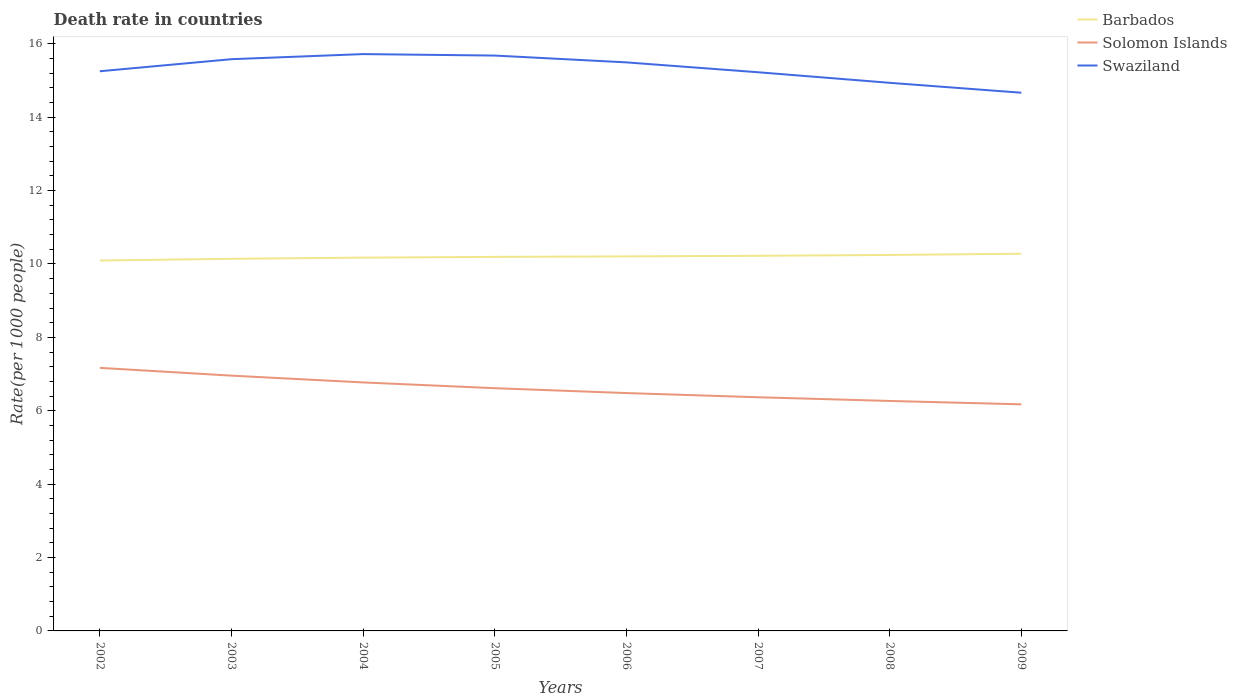Across all years, what is the maximum death rate in Swaziland?
Your response must be concise. 14.67. What is the total death rate in Swaziland in the graph?
Your answer should be compact. 1.05. What is the difference between the highest and the second highest death rate in Swaziland?
Provide a short and direct response. 1.05. Is the death rate in Swaziland strictly greater than the death rate in Solomon Islands over the years?
Give a very brief answer. No. How many lines are there?
Your answer should be compact. 3. Are the values on the major ticks of Y-axis written in scientific E-notation?
Provide a succinct answer. No. Does the graph contain any zero values?
Provide a short and direct response. No. Where does the legend appear in the graph?
Provide a short and direct response. Top right. How are the legend labels stacked?
Your answer should be very brief. Vertical. What is the title of the graph?
Ensure brevity in your answer.  Death rate in countries. Does "Seychelles" appear as one of the legend labels in the graph?
Keep it short and to the point. No. What is the label or title of the Y-axis?
Your response must be concise. Rate(per 1000 people). What is the Rate(per 1000 people) of Barbados in 2002?
Offer a very short reply. 10.1. What is the Rate(per 1000 people) of Solomon Islands in 2002?
Ensure brevity in your answer.  7.17. What is the Rate(per 1000 people) of Swaziland in 2002?
Your answer should be compact. 15.25. What is the Rate(per 1000 people) of Barbados in 2003?
Your answer should be very brief. 10.14. What is the Rate(per 1000 people) of Solomon Islands in 2003?
Your answer should be compact. 6.96. What is the Rate(per 1000 people) of Swaziland in 2003?
Your answer should be very brief. 15.58. What is the Rate(per 1000 people) of Barbados in 2004?
Provide a succinct answer. 10.17. What is the Rate(per 1000 people) in Solomon Islands in 2004?
Offer a terse response. 6.77. What is the Rate(per 1000 people) of Swaziland in 2004?
Your response must be concise. 15.72. What is the Rate(per 1000 people) of Barbados in 2005?
Keep it short and to the point. 10.19. What is the Rate(per 1000 people) of Solomon Islands in 2005?
Your answer should be compact. 6.62. What is the Rate(per 1000 people) in Swaziland in 2005?
Your answer should be very brief. 15.68. What is the Rate(per 1000 people) of Barbados in 2006?
Your answer should be very brief. 10.21. What is the Rate(per 1000 people) of Solomon Islands in 2006?
Provide a succinct answer. 6.48. What is the Rate(per 1000 people) in Swaziland in 2006?
Give a very brief answer. 15.49. What is the Rate(per 1000 people) of Barbados in 2007?
Give a very brief answer. 10.22. What is the Rate(per 1000 people) of Solomon Islands in 2007?
Offer a very short reply. 6.37. What is the Rate(per 1000 people) in Swaziland in 2007?
Your answer should be compact. 15.22. What is the Rate(per 1000 people) of Barbados in 2008?
Provide a short and direct response. 10.25. What is the Rate(per 1000 people) of Solomon Islands in 2008?
Ensure brevity in your answer.  6.27. What is the Rate(per 1000 people) in Swaziland in 2008?
Provide a succinct answer. 14.94. What is the Rate(per 1000 people) in Barbados in 2009?
Keep it short and to the point. 10.28. What is the Rate(per 1000 people) in Solomon Islands in 2009?
Provide a succinct answer. 6.17. What is the Rate(per 1000 people) in Swaziland in 2009?
Your answer should be compact. 14.67. Across all years, what is the maximum Rate(per 1000 people) in Barbados?
Offer a terse response. 10.28. Across all years, what is the maximum Rate(per 1000 people) of Solomon Islands?
Give a very brief answer. 7.17. Across all years, what is the maximum Rate(per 1000 people) in Swaziland?
Provide a succinct answer. 15.72. Across all years, what is the minimum Rate(per 1000 people) of Barbados?
Offer a very short reply. 10.1. Across all years, what is the minimum Rate(per 1000 people) of Solomon Islands?
Your response must be concise. 6.17. Across all years, what is the minimum Rate(per 1000 people) in Swaziland?
Offer a terse response. 14.67. What is the total Rate(per 1000 people) of Barbados in the graph?
Offer a terse response. 81.56. What is the total Rate(per 1000 people) of Solomon Islands in the graph?
Give a very brief answer. 52.8. What is the total Rate(per 1000 people) in Swaziland in the graph?
Offer a very short reply. 122.56. What is the difference between the Rate(per 1000 people) in Barbados in 2002 and that in 2003?
Give a very brief answer. -0.05. What is the difference between the Rate(per 1000 people) of Solomon Islands in 2002 and that in 2003?
Ensure brevity in your answer.  0.21. What is the difference between the Rate(per 1000 people) in Swaziland in 2002 and that in 2003?
Offer a terse response. -0.33. What is the difference between the Rate(per 1000 people) in Barbados in 2002 and that in 2004?
Provide a succinct answer. -0.08. What is the difference between the Rate(per 1000 people) in Solomon Islands in 2002 and that in 2004?
Your response must be concise. 0.4. What is the difference between the Rate(per 1000 people) in Swaziland in 2002 and that in 2004?
Give a very brief answer. -0.47. What is the difference between the Rate(per 1000 people) of Barbados in 2002 and that in 2005?
Your answer should be very brief. -0.1. What is the difference between the Rate(per 1000 people) of Solomon Islands in 2002 and that in 2005?
Your response must be concise. 0.55. What is the difference between the Rate(per 1000 people) in Swaziland in 2002 and that in 2005?
Provide a short and direct response. -0.43. What is the difference between the Rate(per 1000 people) of Barbados in 2002 and that in 2006?
Your response must be concise. -0.11. What is the difference between the Rate(per 1000 people) in Solomon Islands in 2002 and that in 2006?
Give a very brief answer. 0.69. What is the difference between the Rate(per 1000 people) in Swaziland in 2002 and that in 2006?
Your response must be concise. -0.24. What is the difference between the Rate(per 1000 people) in Barbados in 2002 and that in 2007?
Keep it short and to the point. -0.13. What is the difference between the Rate(per 1000 people) in Solomon Islands in 2002 and that in 2007?
Your answer should be very brief. 0.8. What is the difference between the Rate(per 1000 people) of Swaziland in 2002 and that in 2007?
Your response must be concise. 0.03. What is the difference between the Rate(per 1000 people) of Barbados in 2002 and that in 2008?
Provide a succinct answer. -0.15. What is the difference between the Rate(per 1000 people) of Solomon Islands in 2002 and that in 2008?
Your response must be concise. 0.9. What is the difference between the Rate(per 1000 people) of Swaziland in 2002 and that in 2008?
Keep it short and to the point. 0.32. What is the difference between the Rate(per 1000 people) of Barbados in 2002 and that in 2009?
Your answer should be very brief. -0.18. What is the difference between the Rate(per 1000 people) in Swaziland in 2002 and that in 2009?
Offer a terse response. 0.58. What is the difference between the Rate(per 1000 people) in Barbados in 2003 and that in 2004?
Give a very brief answer. -0.03. What is the difference between the Rate(per 1000 people) of Solomon Islands in 2003 and that in 2004?
Your answer should be very brief. 0.18. What is the difference between the Rate(per 1000 people) of Swaziland in 2003 and that in 2004?
Provide a succinct answer. -0.14. What is the difference between the Rate(per 1000 people) of Barbados in 2003 and that in 2005?
Keep it short and to the point. -0.05. What is the difference between the Rate(per 1000 people) in Solomon Islands in 2003 and that in 2005?
Your answer should be compact. 0.34. What is the difference between the Rate(per 1000 people) of Swaziland in 2003 and that in 2005?
Your answer should be compact. -0.1. What is the difference between the Rate(per 1000 people) in Barbados in 2003 and that in 2006?
Provide a short and direct response. -0.07. What is the difference between the Rate(per 1000 people) of Solomon Islands in 2003 and that in 2006?
Your answer should be very brief. 0.47. What is the difference between the Rate(per 1000 people) in Swaziland in 2003 and that in 2006?
Make the answer very short. 0.09. What is the difference between the Rate(per 1000 people) in Barbados in 2003 and that in 2007?
Give a very brief answer. -0.08. What is the difference between the Rate(per 1000 people) of Solomon Islands in 2003 and that in 2007?
Give a very brief answer. 0.59. What is the difference between the Rate(per 1000 people) in Swaziland in 2003 and that in 2007?
Keep it short and to the point. 0.36. What is the difference between the Rate(per 1000 people) in Barbados in 2003 and that in 2008?
Ensure brevity in your answer.  -0.1. What is the difference between the Rate(per 1000 people) in Solomon Islands in 2003 and that in 2008?
Offer a very short reply. 0.69. What is the difference between the Rate(per 1000 people) of Swaziland in 2003 and that in 2008?
Make the answer very short. 0.64. What is the difference between the Rate(per 1000 people) of Barbados in 2003 and that in 2009?
Offer a very short reply. -0.14. What is the difference between the Rate(per 1000 people) in Solomon Islands in 2003 and that in 2009?
Offer a terse response. 0.78. What is the difference between the Rate(per 1000 people) in Swaziland in 2003 and that in 2009?
Make the answer very short. 0.91. What is the difference between the Rate(per 1000 people) of Barbados in 2004 and that in 2005?
Keep it short and to the point. -0.02. What is the difference between the Rate(per 1000 people) in Solomon Islands in 2004 and that in 2005?
Offer a terse response. 0.16. What is the difference between the Rate(per 1000 people) in Swaziland in 2004 and that in 2005?
Keep it short and to the point. 0.04. What is the difference between the Rate(per 1000 people) in Barbados in 2004 and that in 2006?
Your answer should be compact. -0.03. What is the difference between the Rate(per 1000 people) of Solomon Islands in 2004 and that in 2006?
Provide a succinct answer. 0.29. What is the difference between the Rate(per 1000 people) in Swaziland in 2004 and that in 2006?
Offer a terse response. 0.23. What is the difference between the Rate(per 1000 people) in Solomon Islands in 2004 and that in 2007?
Your answer should be very brief. 0.4. What is the difference between the Rate(per 1000 people) in Swaziland in 2004 and that in 2007?
Make the answer very short. 0.49. What is the difference between the Rate(per 1000 people) in Barbados in 2004 and that in 2008?
Provide a short and direct response. -0.07. What is the difference between the Rate(per 1000 people) of Solomon Islands in 2004 and that in 2008?
Give a very brief answer. 0.51. What is the difference between the Rate(per 1000 people) of Swaziland in 2004 and that in 2008?
Your answer should be very brief. 0.78. What is the difference between the Rate(per 1000 people) of Barbados in 2004 and that in 2009?
Provide a succinct answer. -0.11. What is the difference between the Rate(per 1000 people) in Solomon Islands in 2004 and that in 2009?
Your response must be concise. 0.6. What is the difference between the Rate(per 1000 people) in Swaziland in 2004 and that in 2009?
Offer a terse response. 1.05. What is the difference between the Rate(per 1000 people) of Barbados in 2005 and that in 2006?
Keep it short and to the point. -0.01. What is the difference between the Rate(per 1000 people) in Solomon Islands in 2005 and that in 2006?
Your response must be concise. 0.13. What is the difference between the Rate(per 1000 people) of Swaziland in 2005 and that in 2006?
Keep it short and to the point. 0.19. What is the difference between the Rate(per 1000 people) in Barbados in 2005 and that in 2007?
Provide a succinct answer. -0.03. What is the difference between the Rate(per 1000 people) of Solomon Islands in 2005 and that in 2007?
Your answer should be very brief. 0.25. What is the difference between the Rate(per 1000 people) in Swaziland in 2005 and that in 2007?
Make the answer very short. 0.46. What is the difference between the Rate(per 1000 people) in Barbados in 2005 and that in 2008?
Provide a succinct answer. -0.05. What is the difference between the Rate(per 1000 people) in Solomon Islands in 2005 and that in 2008?
Offer a very short reply. 0.35. What is the difference between the Rate(per 1000 people) of Swaziland in 2005 and that in 2008?
Provide a short and direct response. 0.74. What is the difference between the Rate(per 1000 people) in Barbados in 2005 and that in 2009?
Provide a succinct answer. -0.09. What is the difference between the Rate(per 1000 people) of Solomon Islands in 2005 and that in 2009?
Keep it short and to the point. 0.44. What is the difference between the Rate(per 1000 people) of Barbados in 2006 and that in 2007?
Your answer should be very brief. -0.02. What is the difference between the Rate(per 1000 people) of Solomon Islands in 2006 and that in 2007?
Keep it short and to the point. 0.11. What is the difference between the Rate(per 1000 people) of Swaziland in 2006 and that in 2007?
Your response must be concise. 0.27. What is the difference between the Rate(per 1000 people) in Barbados in 2006 and that in 2008?
Offer a terse response. -0.04. What is the difference between the Rate(per 1000 people) in Solomon Islands in 2006 and that in 2008?
Make the answer very short. 0.21. What is the difference between the Rate(per 1000 people) of Swaziland in 2006 and that in 2008?
Your answer should be very brief. 0.56. What is the difference between the Rate(per 1000 people) of Barbados in 2006 and that in 2009?
Offer a terse response. -0.07. What is the difference between the Rate(per 1000 people) of Solomon Islands in 2006 and that in 2009?
Provide a succinct answer. 0.31. What is the difference between the Rate(per 1000 people) of Swaziland in 2006 and that in 2009?
Provide a short and direct response. 0.83. What is the difference between the Rate(per 1000 people) of Barbados in 2007 and that in 2008?
Provide a succinct answer. -0.02. What is the difference between the Rate(per 1000 people) of Solomon Islands in 2007 and that in 2008?
Give a very brief answer. 0.1. What is the difference between the Rate(per 1000 people) in Swaziland in 2007 and that in 2008?
Ensure brevity in your answer.  0.29. What is the difference between the Rate(per 1000 people) in Barbados in 2007 and that in 2009?
Offer a very short reply. -0.06. What is the difference between the Rate(per 1000 people) in Solomon Islands in 2007 and that in 2009?
Offer a terse response. 0.19. What is the difference between the Rate(per 1000 people) in Swaziland in 2007 and that in 2009?
Your response must be concise. 0.56. What is the difference between the Rate(per 1000 people) in Barbados in 2008 and that in 2009?
Provide a succinct answer. -0.03. What is the difference between the Rate(per 1000 people) of Solomon Islands in 2008 and that in 2009?
Keep it short and to the point. 0.09. What is the difference between the Rate(per 1000 people) of Swaziland in 2008 and that in 2009?
Ensure brevity in your answer.  0.27. What is the difference between the Rate(per 1000 people) in Barbados in 2002 and the Rate(per 1000 people) in Solomon Islands in 2003?
Make the answer very short. 3.14. What is the difference between the Rate(per 1000 people) of Barbados in 2002 and the Rate(per 1000 people) of Swaziland in 2003?
Your response must be concise. -5.49. What is the difference between the Rate(per 1000 people) of Solomon Islands in 2002 and the Rate(per 1000 people) of Swaziland in 2003?
Offer a very short reply. -8.41. What is the difference between the Rate(per 1000 people) in Barbados in 2002 and the Rate(per 1000 people) in Solomon Islands in 2004?
Provide a short and direct response. 3.32. What is the difference between the Rate(per 1000 people) in Barbados in 2002 and the Rate(per 1000 people) in Swaziland in 2004?
Make the answer very short. -5.62. What is the difference between the Rate(per 1000 people) in Solomon Islands in 2002 and the Rate(per 1000 people) in Swaziland in 2004?
Give a very brief answer. -8.55. What is the difference between the Rate(per 1000 people) of Barbados in 2002 and the Rate(per 1000 people) of Solomon Islands in 2005?
Your answer should be very brief. 3.48. What is the difference between the Rate(per 1000 people) in Barbados in 2002 and the Rate(per 1000 people) in Swaziland in 2005?
Make the answer very short. -5.58. What is the difference between the Rate(per 1000 people) in Solomon Islands in 2002 and the Rate(per 1000 people) in Swaziland in 2005?
Offer a very short reply. -8.51. What is the difference between the Rate(per 1000 people) in Barbados in 2002 and the Rate(per 1000 people) in Solomon Islands in 2006?
Your answer should be very brief. 3.61. What is the difference between the Rate(per 1000 people) in Barbados in 2002 and the Rate(per 1000 people) in Swaziland in 2006?
Ensure brevity in your answer.  -5.4. What is the difference between the Rate(per 1000 people) in Solomon Islands in 2002 and the Rate(per 1000 people) in Swaziland in 2006?
Make the answer very short. -8.32. What is the difference between the Rate(per 1000 people) in Barbados in 2002 and the Rate(per 1000 people) in Solomon Islands in 2007?
Ensure brevity in your answer.  3.73. What is the difference between the Rate(per 1000 people) in Barbados in 2002 and the Rate(per 1000 people) in Swaziland in 2007?
Provide a short and direct response. -5.13. What is the difference between the Rate(per 1000 people) in Solomon Islands in 2002 and the Rate(per 1000 people) in Swaziland in 2007?
Your response must be concise. -8.06. What is the difference between the Rate(per 1000 people) in Barbados in 2002 and the Rate(per 1000 people) in Solomon Islands in 2008?
Give a very brief answer. 3.83. What is the difference between the Rate(per 1000 people) in Barbados in 2002 and the Rate(per 1000 people) in Swaziland in 2008?
Your answer should be very brief. -4.84. What is the difference between the Rate(per 1000 people) of Solomon Islands in 2002 and the Rate(per 1000 people) of Swaziland in 2008?
Keep it short and to the point. -7.77. What is the difference between the Rate(per 1000 people) of Barbados in 2002 and the Rate(per 1000 people) of Solomon Islands in 2009?
Make the answer very short. 3.92. What is the difference between the Rate(per 1000 people) of Barbados in 2002 and the Rate(per 1000 people) of Swaziland in 2009?
Offer a very short reply. -4.57. What is the difference between the Rate(per 1000 people) of Solomon Islands in 2002 and the Rate(per 1000 people) of Swaziland in 2009?
Provide a short and direct response. -7.5. What is the difference between the Rate(per 1000 people) of Barbados in 2003 and the Rate(per 1000 people) of Solomon Islands in 2004?
Ensure brevity in your answer.  3.37. What is the difference between the Rate(per 1000 people) in Barbados in 2003 and the Rate(per 1000 people) in Swaziland in 2004?
Your answer should be very brief. -5.58. What is the difference between the Rate(per 1000 people) in Solomon Islands in 2003 and the Rate(per 1000 people) in Swaziland in 2004?
Your response must be concise. -8.76. What is the difference between the Rate(per 1000 people) of Barbados in 2003 and the Rate(per 1000 people) of Solomon Islands in 2005?
Your answer should be compact. 3.53. What is the difference between the Rate(per 1000 people) in Barbados in 2003 and the Rate(per 1000 people) in Swaziland in 2005?
Provide a short and direct response. -5.54. What is the difference between the Rate(per 1000 people) of Solomon Islands in 2003 and the Rate(per 1000 people) of Swaziland in 2005?
Your answer should be very brief. -8.72. What is the difference between the Rate(per 1000 people) in Barbados in 2003 and the Rate(per 1000 people) in Solomon Islands in 2006?
Make the answer very short. 3.66. What is the difference between the Rate(per 1000 people) in Barbados in 2003 and the Rate(per 1000 people) in Swaziland in 2006?
Provide a succinct answer. -5.35. What is the difference between the Rate(per 1000 people) in Solomon Islands in 2003 and the Rate(per 1000 people) in Swaziland in 2006?
Offer a terse response. -8.54. What is the difference between the Rate(per 1000 people) of Barbados in 2003 and the Rate(per 1000 people) of Solomon Islands in 2007?
Keep it short and to the point. 3.77. What is the difference between the Rate(per 1000 people) of Barbados in 2003 and the Rate(per 1000 people) of Swaziland in 2007?
Give a very brief answer. -5.08. What is the difference between the Rate(per 1000 people) in Solomon Islands in 2003 and the Rate(per 1000 people) in Swaziland in 2007?
Make the answer very short. -8.27. What is the difference between the Rate(per 1000 people) of Barbados in 2003 and the Rate(per 1000 people) of Solomon Islands in 2008?
Your answer should be very brief. 3.87. What is the difference between the Rate(per 1000 people) in Barbados in 2003 and the Rate(per 1000 people) in Swaziland in 2008?
Your response must be concise. -4.8. What is the difference between the Rate(per 1000 people) of Solomon Islands in 2003 and the Rate(per 1000 people) of Swaziland in 2008?
Your response must be concise. -7.98. What is the difference between the Rate(per 1000 people) in Barbados in 2003 and the Rate(per 1000 people) in Solomon Islands in 2009?
Provide a succinct answer. 3.97. What is the difference between the Rate(per 1000 people) in Barbados in 2003 and the Rate(per 1000 people) in Swaziland in 2009?
Offer a very short reply. -4.53. What is the difference between the Rate(per 1000 people) of Solomon Islands in 2003 and the Rate(per 1000 people) of Swaziland in 2009?
Your answer should be very brief. -7.71. What is the difference between the Rate(per 1000 people) of Barbados in 2004 and the Rate(per 1000 people) of Solomon Islands in 2005?
Your answer should be compact. 3.56. What is the difference between the Rate(per 1000 people) of Barbados in 2004 and the Rate(per 1000 people) of Swaziland in 2005?
Give a very brief answer. -5.51. What is the difference between the Rate(per 1000 people) in Solomon Islands in 2004 and the Rate(per 1000 people) in Swaziland in 2005?
Provide a short and direct response. -8.91. What is the difference between the Rate(per 1000 people) of Barbados in 2004 and the Rate(per 1000 people) of Solomon Islands in 2006?
Your answer should be compact. 3.69. What is the difference between the Rate(per 1000 people) in Barbados in 2004 and the Rate(per 1000 people) in Swaziland in 2006?
Provide a succinct answer. -5.32. What is the difference between the Rate(per 1000 people) of Solomon Islands in 2004 and the Rate(per 1000 people) of Swaziland in 2006?
Ensure brevity in your answer.  -8.72. What is the difference between the Rate(per 1000 people) of Barbados in 2004 and the Rate(per 1000 people) of Solomon Islands in 2007?
Your answer should be compact. 3.81. What is the difference between the Rate(per 1000 people) in Barbados in 2004 and the Rate(per 1000 people) in Swaziland in 2007?
Offer a terse response. -5.05. What is the difference between the Rate(per 1000 people) of Solomon Islands in 2004 and the Rate(per 1000 people) of Swaziland in 2007?
Your response must be concise. -8.45. What is the difference between the Rate(per 1000 people) in Barbados in 2004 and the Rate(per 1000 people) in Solomon Islands in 2008?
Provide a short and direct response. 3.91. What is the difference between the Rate(per 1000 people) of Barbados in 2004 and the Rate(per 1000 people) of Swaziland in 2008?
Your answer should be compact. -4.76. What is the difference between the Rate(per 1000 people) of Solomon Islands in 2004 and the Rate(per 1000 people) of Swaziland in 2008?
Make the answer very short. -8.16. What is the difference between the Rate(per 1000 people) of Barbados in 2004 and the Rate(per 1000 people) of Solomon Islands in 2009?
Offer a very short reply. 4. What is the difference between the Rate(per 1000 people) in Barbados in 2004 and the Rate(per 1000 people) in Swaziland in 2009?
Keep it short and to the point. -4.49. What is the difference between the Rate(per 1000 people) of Solomon Islands in 2004 and the Rate(per 1000 people) of Swaziland in 2009?
Your answer should be very brief. -7.89. What is the difference between the Rate(per 1000 people) of Barbados in 2005 and the Rate(per 1000 people) of Solomon Islands in 2006?
Your answer should be very brief. 3.71. What is the difference between the Rate(per 1000 people) in Barbados in 2005 and the Rate(per 1000 people) in Swaziland in 2006?
Your response must be concise. -5.3. What is the difference between the Rate(per 1000 people) in Solomon Islands in 2005 and the Rate(per 1000 people) in Swaziland in 2006?
Your answer should be very brief. -8.88. What is the difference between the Rate(per 1000 people) in Barbados in 2005 and the Rate(per 1000 people) in Solomon Islands in 2007?
Offer a terse response. 3.83. What is the difference between the Rate(per 1000 people) of Barbados in 2005 and the Rate(per 1000 people) of Swaziland in 2007?
Provide a short and direct response. -5.03. What is the difference between the Rate(per 1000 people) of Solomon Islands in 2005 and the Rate(per 1000 people) of Swaziland in 2007?
Your answer should be compact. -8.61. What is the difference between the Rate(per 1000 people) of Barbados in 2005 and the Rate(per 1000 people) of Solomon Islands in 2008?
Offer a terse response. 3.93. What is the difference between the Rate(per 1000 people) of Barbados in 2005 and the Rate(per 1000 people) of Swaziland in 2008?
Offer a terse response. -4.74. What is the difference between the Rate(per 1000 people) of Solomon Islands in 2005 and the Rate(per 1000 people) of Swaziland in 2008?
Offer a very short reply. -8.32. What is the difference between the Rate(per 1000 people) of Barbados in 2005 and the Rate(per 1000 people) of Solomon Islands in 2009?
Provide a short and direct response. 4.02. What is the difference between the Rate(per 1000 people) in Barbados in 2005 and the Rate(per 1000 people) in Swaziland in 2009?
Offer a very short reply. -4.47. What is the difference between the Rate(per 1000 people) in Solomon Islands in 2005 and the Rate(per 1000 people) in Swaziland in 2009?
Keep it short and to the point. -8.05. What is the difference between the Rate(per 1000 people) in Barbados in 2006 and the Rate(per 1000 people) in Solomon Islands in 2007?
Your answer should be compact. 3.84. What is the difference between the Rate(per 1000 people) in Barbados in 2006 and the Rate(per 1000 people) in Swaziland in 2007?
Your response must be concise. -5.02. What is the difference between the Rate(per 1000 people) of Solomon Islands in 2006 and the Rate(per 1000 people) of Swaziland in 2007?
Keep it short and to the point. -8.74. What is the difference between the Rate(per 1000 people) in Barbados in 2006 and the Rate(per 1000 people) in Solomon Islands in 2008?
Make the answer very short. 3.94. What is the difference between the Rate(per 1000 people) of Barbados in 2006 and the Rate(per 1000 people) of Swaziland in 2008?
Provide a short and direct response. -4.73. What is the difference between the Rate(per 1000 people) in Solomon Islands in 2006 and the Rate(per 1000 people) in Swaziland in 2008?
Make the answer very short. -8.46. What is the difference between the Rate(per 1000 people) of Barbados in 2006 and the Rate(per 1000 people) of Solomon Islands in 2009?
Provide a short and direct response. 4.03. What is the difference between the Rate(per 1000 people) of Barbados in 2006 and the Rate(per 1000 people) of Swaziland in 2009?
Provide a succinct answer. -4.46. What is the difference between the Rate(per 1000 people) in Solomon Islands in 2006 and the Rate(per 1000 people) in Swaziland in 2009?
Provide a succinct answer. -8.19. What is the difference between the Rate(per 1000 people) of Barbados in 2007 and the Rate(per 1000 people) of Solomon Islands in 2008?
Provide a short and direct response. 3.96. What is the difference between the Rate(per 1000 people) in Barbados in 2007 and the Rate(per 1000 people) in Swaziland in 2008?
Your answer should be very brief. -4.71. What is the difference between the Rate(per 1000 people) of Solomon Islands in 2007 and the Rate(per 1000 people) of Swaziland in 2008?
Your answer should be very brief. -8.57. What is the difference between the Rate(per 1000 people) in Barbados in 2007 and the Rate(per 1000 people) in Solomon Islands in 2009?
Your answer should be very brief. 4.05. What is the difference between the Rate(per 1000 people) of Barbados in 2007 and the Rate(per 1000 people) of Swaziland in 2009?
Provide a short and direct response. -4.44. What is the difference between the Rate(per 1000 people) of Solomon Islands in 2007 and the Rate(per 1000 people) of Swaziland in 2009?
Ensure brevity in your answer.  -8.3. What is the difference between the Rate(per 1000 people) in Barbados in 2008 and the Rate(per 1000 people) in Solomon Islands in 2009?
Your answer should be very brief. 4.07. What is the difference between the Rate(per 1000 people) in Barbados in 2008 and the Rate(per 1000 people) in Swaziland in 2009?
Keep it short and to the point. -4.42. What is the average Rate(per 1000 people) of Barbados per year?
Make the answer very short. 10.19. What is the average Rate(per 1000 people) in Solomon Islands per year?
Ensure brevity in your answer.  6.6. What is the average Rate(per 1000 people) of Swaziland per year?
Your response must be concise. 15.32. In the year 2002, what is the difference between the Rate(per 1000 people) in Barbados and Rate(per 1000 people) in Solomon Islands?
Your answer should be very brief. 2.93. In the year 2002, what is the difference between the Rate(per 1000 people) of Barbados and Rate(per 1000 people) of Swaziland?
Offer a very short reply. -5.16. In the year 2002, what is the difference between the Rate(per 1000 people) of Solomon Islands and Rate(per 1000 people) of Swaziland?
Ensure brevity in your answer.  -8.08. In the year 2003, what is the difference between the Rate(per 1000 people) in Barbados and Rate(per 1000 people) in Solomon Islands?
Provide a succinct answer. 3.18. In the year 2003, what is the difference between the Rate(per 1000 people) in Barbados and Rate(per 1000 people) in Swaziland?
Ensure brevity in your answer.  -5.44. In the year 2003, what is the difference between the Rate(per 1000 people) of Solomon Islands and Rate(per 1000 people) of Swaziland?
Keep it short and to the point. -8.62. In the year 2004, what is the difference between the Rate(per 1000 people) of Barbados and Rate(per 1000 people) of Solomon Islands?
Your response must be concise. 3.4. In the year 2004, what is the difference between the Rate(per 1000 people) of Barbados and Rate(per 1000 people) of Swaziland?
Provide a succinct answer. -5.55. In the year 2004, what is the difference between the Rate(per 1000 people) of Solomon Islands and Rate(per 1000 people) of Swaziland?
Provide a succinct answer. -8.95. In the year 2005, what is the difference between the Rate(per 1000 people) of Barbados and Rate(per 1000 people) of Solomon Islands?
Your response must be concise. 3.58. In the year 2005, what is the difference between the Rate(per 1000 people) in Barbados and Rate(per 1000 people) in Swaziland?
Offer a very short reply. -5.49. In the year 2005, what is the difference between the Rate(per 1000 people) of Solomon Islands and Rate(per 1000 people) of Swaziland?
Provide a short and direct response. -9.06. In the year 2006, what is the difference between the Rate(per 1000 people) of Barbados and Rate(per 1000 people) of Solomon Islands?
Provide a short and direct response. 3.73. In the year 2006, what is the difference between the Rate(per 1000 people) of Barbados and Rate(per 1000 people) of Swaziland?
Keep it short and to the point. -5.29. In the year 2006, what is the difference between the Rate(per 1000 people) of Solomon Islands and Rate(per 1000 people) of Swaziland?
Your answer should be compact. -9.01. In the year 2007, what is the difference between the Rate(per 1000 people) of Barbados and Rate(per 1000 people) of Solomon Islands?
Ensure brevity in your answer.  3.85. In the year 2007, what is the difference between the Rate(per 1000 people) in Barbados and Rate(per 1000 people) in Swaziland?
Your response must be concise. -5. In the year 2007, what is the difference between the Rate(per 1000 people) of Solomon Islands and Rate(per 1000 people) of Swaziland?
Your answer should be very brief. -8.86. In the year 2008, what is the difference between the Rate(per 1000 people) of Barbados and Rate(per 1000 people) of Solomon Islands?
Provide a short and direct response. 3.98. In the year 2008, what is the difference between the Rate(per 1000 people) in Barbados and Rate(per 1000 people) in Swaziland?
Provide a short and direct response. -4.69. In the year 2008, what is the difference between the Rate(per 1000 people) in Solomon Islands and Rate(per 1000 people) in Swaziland?
Your answer should be compact. -8.67. In the year 2009, what is the difference between the Rate(per 1000 people) of Barbados and Rate(per 1000 people) of Solomon Islands?
Offer a very short reply. 4.1. In the year 2009, what is the difference between the Rate(per 1000 people) of Barbados and Rate(per 1000 people) of Swaziland?
Give a very brief answer. -4.39. In the year 2009, what is the difference between the Rate(per 1000 people) of Solomon Islands and Rate(per 1000 people) of Swaziland?
Give a very brief answer. -8.49. What is the ratio of the Rate(per 1000 people) of Barbados in 2002 to that in 2003?
Offer a terse response. 1. What is the ratio of the Rate(per 1000 people) of Solomon Islands in 2002 to that in 2003?
Your answer should be compact. 1.03. What is the ratio of the Rate(per 1000 people) of Swaziland in 2002 to that in 2003?
Make the answer very short. 0.98. What is the ratio of the Rate(per 1000 people) in Solomon Islands in 2002 to that in 2004?
Provide a short and direct response. 1.06. What is the ratio of the Rate(per 1000 people) in Swaziland in 2002 to that in 2004?
Provide a short and direct response. 0.97. What is the ratio of the Rate(per 1000 people) of Solomon Islands in 2002 to that in 2005?
Your answer should be very brief. 1.08. What is the ratio of the Rate(per 1000 people) in Swaziland in 2002 to that in 2005?
Ensure brevity in your answer.  0.97. What is the ratio of the Rate(per 1000 people) of Barbados in 2002 to that in 2006?
Give a very brief answer. 0.99. What is the ratio of the Rate(per 1000 people) of Solomon Islands in 2002 to that in 2006?
Keep it short and to the point. 1.11. What is the ratio of the Rate(per 1000 people) of Swaziland in 2002 to that in 2006?
Provide a succinct answer. 0.98. What is the ratio of the Rate(per 1000 people) in Barbados in 2002 to that in 2007?
Make the answer very short. 0.99. What is the ratio of the Rate(per 1000 people) in Solomon Islands in 2002 to that in 2007?
Offer a terse response. 1.13. What is the ratio of the Rate(per 1000 people) in Swaziland in 2002 to that in 2007?
Give a very brief answer. 1. What is the ratio of the Rate(per 1000 people) in Barbados in 2002 to that in 2008?
Offer a very short reply. 0.99. What is the ratio of the Rate(per 1000 people) in Solomon Islands in 2002 to that in 2008?
Your answer should be compact. 1.14. What is the ratio of the Rate(per 1000 people) in Swaziland in 2002 to that in 2008?
Offer a very short reply. 1.02. What is the ratio of the Rate(per 1000 people) in Barbados in 2002 to that in 2009?
Make the answer very short. 0.98. What is the ratio of the Rate(per 1000 people) in Solomon Islands in 2002 to that in 2009?
Ensure brevity in your answer.  1.16. What is the ratio of the Rate(per 1000 people) of Swaziland in 2002 to that in 2009?
Offer a terse response. 1.04. What is the ratio of the Rate(per 1000 people) in Solomon Islands in 2003 to that in 2004?
Your answer should be compact. 1.03. What is the ratio of the Rate(per 1000 people) in Solomon Islands in 2003 to that in 2005?
Give a very brief answer. 1.05. What is the ratio of the Rate(per 1000 people) in Swaziland in 2003 to that in 2005?
Offer a very short reply. 0.99. What is the ratio of the Rate(per 1000 people) in Barbados in 2003 to that in 2006?
Give a very brief answer. 0.99. What is the ratio of the Rate(per 1000 people) of Solomon Islands in 2003 to that in 2006?
Ensure brevity in your answer.  1.07. What is the ratio of the Rate(per 1000 people) in Swaziland in 2003 to that in 2006?
Provide a short and direct response. 1.01. What is the ratio of the Rate(per 1000 people) in Barbados in 2003 to that in 2007?
Make the answer very short. 0.99. What is the ratio of the Rate(per 1000 people) of Solomon Islands in 2003 to that in 2007?
Offer a terse response. 1.09. What is the ratio of the Rate(per 1000 people) in Swaziland in 2003 to that in 2007?
Your response must be concise. 1.02. What is the ratio of the Rate(per 1000 people) in Barbados in 2003 to that in 2008?
Keep it short and to the point. 0.99. What is the ratio of the Rate(per 1000 people) of Solomon Islands in 2003 to that in 2008?
Your answer should be very brief. 1.11. What is the ratio of the Rate(per 1000 people) in Swaziland in 2003 to that in 2008?
Provide a succinct answer. 1.04. What is the ratio of the Rate(per 1000 people) of Barbados in 2003 to that in 2009?
Provide a succinct answer. 0.99. What is the ratio of the Rate(per 1000 people) in Solomon Islands in 2003 to that in 2009?
Your response must be concise. 1.13. What is the ratio of the Rate(per 1000 people) of Swaziland in 2003 to that in 2009?
Offer a very short reply. 1.06. What is the ratio of the Rate(per 1000 people) of Solomon Islands in 2004 to that in 2005?
Your answer should be very brief. 1.02. What is the ratio of the Rate(per 1000 people) in Swaziland in 2004 to that in 2005?
Offer a terse response. 1. What is the ratio of the Rate(per 1000 people) in Solomon Islands in 2004 to that in 2006?
Make the answer very short. 1.04. What is the ratio of the Rate(per 1000 people) in Swaziland in 2004 to that in 2006?
Your response must be concise. 1.01. What is the ratio of the Rate(per 1000 people) of Barbados in 2004 to that in 2007?
Keep it short and to the point. 1. What is the ratio of the Rate(per 1000 people) in Solomon Islands in 2004 to that in 2007?
Your answer should be compact. 1.06. What is the ratio of the Rate(per 1000 people) in Swaziland in 2004 to that in 2007?
Your answer should be compact. 1.03. What is the ratio of the Rate(per 1000 people) of Barbados in 2004 to that in 2008?
Provide a short and direct response. 0.99. What is the ratio of the Rate(per 1000 people) of Solomon Islands in 2004 to that in 2008?
Your answer should be very brief. 1.08. What is the ratio of the Rate(per 1000 people) of Swaziland in 2004 to that in 2008?
Provide a short and direct response. 1.05. What is the ratio of the Rate(per 1000 people) of Barbados in 2004 to that in 2009?
Your answer should be compact. 0.99. What is the ratio of the Rate(per 1000 people) in Solomon Islands in 2004 to that in 2009?
Your answer should be very brief. 1.1. What is the ratio of the Rate(per 1000 people) of Swaziland in 2004 to that in 2009?
Ensure brevity in your answer.  1.07. What is the ratio of the Rate(per 1000 people) of Barbados in 2005 to that in 2006?
Give a very brief answer. 1. What is the ratio of the Rate(per 1000 people) of Solomon Islands in 2005 to that in 2006?
Your answer should be very brief. 1.02. What is the ratio of the Rate(per 1000 people) of Barbados in 2005 to that in 2007?
Your response must be concise. 1. What is the ratio of the Rate(per 1000 people) of Solomon Islands in 2005 to that in 2007?
Offer a terse response. 1.04. What is the ratio of the Rate(per 1000 people) of Swaziland in 2005 to that in 2007?
Your response must be concise. 1.03. What is the ratio of the Rate(per 1000 people) of Barbados in 2005 to that in 2008?
Keep it short and to the point. 0.99. What is the ratio of the Rate(per 1000 people) in Solomon Islands in 2005 to that in 2008?
Ensure brevity in your answer.  1.06. What is the ratio of the Rate(per 1000 people) in Swaziland in 2005 to that in 2008?
Give a very brief answer. 1.05. What is the ratio of the Rate(per 1000 people) of Barbados in 2005 to that in 2009?
Ensure brevity in your answer.  0.99. What is the ratio of the Rate(per 1000 people) in Solomon Islands in 2005 to that in 2009?
Give a very brief answer. 1.07. What is the ratio of the Rate(per 1000 people) in Swaziland in 2005 to that in 2009?
Provide a short and direct response. 1.07. What is the ratio of the Rate(per 1000 people) in Solomon Islands in 2006 to that in 2007?
Provide a succinct answer. 1.02. What is the ratio of the Rate(per 1000 people) of Swaziland in 2006 to that in 2007?
Provide a short and direct response. 1.02. What is the ratio of the Rate(per 1000 people) of Barbados in 2006 to that in 2008?
Keep it short and to the point. 1. What is the ratio of the Rate(per 1000 people) in Solomon Islands in 2006 to that in 2008?
Ensure brevity in your answer.  1.03. What is the ratio of the Rate(per 1000 people) of Swaziland in 2006 to that in 2008?
Ensure brevity in your answer.  1.04. What is the ratio of the Rate(per 1000 people) in Solomon Islands in 2006 to that in 2009?
Your response must be concise. 1.05. What is the ratio of the Rate(per 1000 people) in Swaziland in 2006 to that in 2009?
Provide a succinct answer. 1.06. What is the ratio of the Rate(per 1000 people) of Barbados in 2007 to that in 2008?
Give a very brief answer. 1. What is the ratio of the Rate(per 1000 people) in Solomon Islands in 2007 to that in 2008?
Offer a very short reply. 1.02. What is the ratio of the Rate(per 1000 people) in Swaziland in 2007 to that in 2008?
Your answer should be compact. 1.02. What is the ratio of the Rate(per 1000 people) of Solomon Islands in 2007 to that in 2009?
Keep it short and to the point. 1.03. What is the ratio of the Rate(per 1000 people) of Swaziland in 2007 to that in 2009?
Keep it short and to the point. 1.04. What is the ratio of the Rate(per 1000 people) of Barbados in 2008 to that in 2009?
Your answer should be very brief. 1. What is the ratio of the Rate(per 1000 people) in Solomon Islands in 2008 to that in 2009?
Make the answer very short. 1.01. What is the ratio of the Rate(per 1000 people) of Swaziland in 2008 to that in 2009?
Your response must be concise. 1.02. What is the difference between the highest and the second highest Rate(per 1000 people) of Barbados?
Ensure brevity in your answer.  0.03. What is the difference between the highest and the second highest Rate(per 1000 people) of Solomon Islands?
Ensure brevity in your answer.  0.21. What is the difference between the highest and the second highest Rate(per 1000 people) of Swaziland?
Your answer should be compact. 0.04. What is the difference between the highest and the lowest Rate(per 1000 people) in Barbados?
Provide a short and direct response. 0.18. What is the difference between the highest and the lowest Rate(per 1000 people) of Swaziland?
Provide a succinct answer. 1.05. 